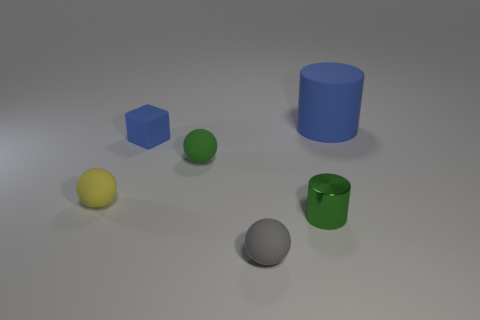Could you guess the size of these objects relative to each other? While the exact sizes are unclear without a reference, the relative sizes suggest the blue cube and the green cylinder are larger than the yellow sphere and the gray sphere, which seem comparable in size to the small green sphere. 